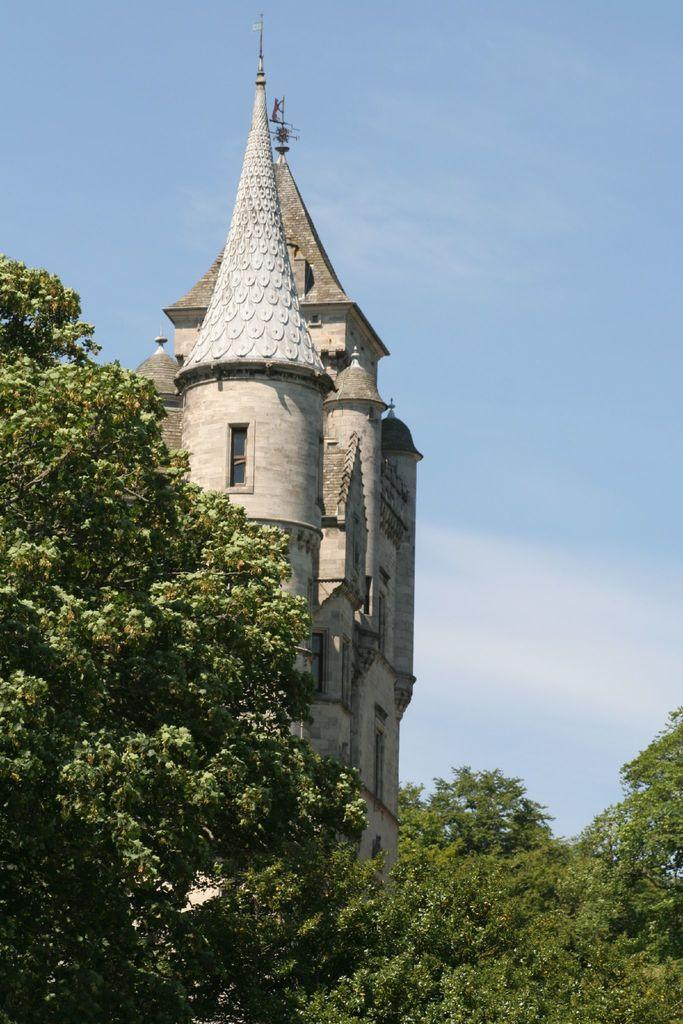What type of structure is visible in the image? There is a building with windows in the image. What other objects can be seen in the image? There are poles and a tower visible in the image. What is located at the bottom of the image? There is a group of trees at the bottom of the image. What is visible at the top of the image? The sky is visible at the top of the image. Where is the throne located in the image? There is no throne present in the image. What direction is the mountain facing in the image? There is no mountain present in the image. 